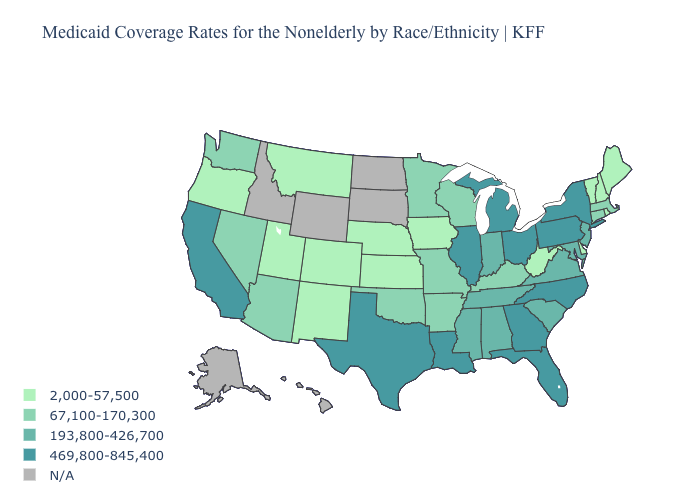Is the legend a continuous bar?
Short answer required. No. What is the highest value in the USA?
Give a very brief answer. 469,800-845,400. Which states have the lowest value in the Northeast?
Write a very short answer. Maine, New Hampshire, Rhode Island, Vermont. Name the states that have a value in the range 2,000-57,500?
Give a very brief answer. Colorado, Delaware, Iowa, Kansas, Maine, Montana, Nebraska, New Hampshire, New Mexico, Oregon, Rhode Island, Utah, Vermont, West Virginia. How many symbols are there in the legend?
Quick response, please. 5. Among the states that border Indiana , which have the lowest value?
Give a very brief answer. Kentucky. How many symbols are there in the legend?
Write a very short answer. 5. Does North Carolina have the lowest value in the South?
Short answer required. No. Does the map have missing data?
Keep it brief. Yes. What is the value of Mississippi?
Give a very brief answer. 193,800-426,700. Name the states that have a value in the range 67,100-170,300?
Short answer required. Arizona, Arkansas, Connecticut, Kentucky, Massachusetts, Minnesota, Missouri, Nevada, Oklahoma, Washington, Wisconsin. What is the highest value in the MidWest ?
Be succinct. 469,800-845,400. What is the highest value in the USA?
Keep it brief. 469,800-845,400. Which states hav the highest value in the Northeast?
Be succinct. New York, Pennsylvania. 